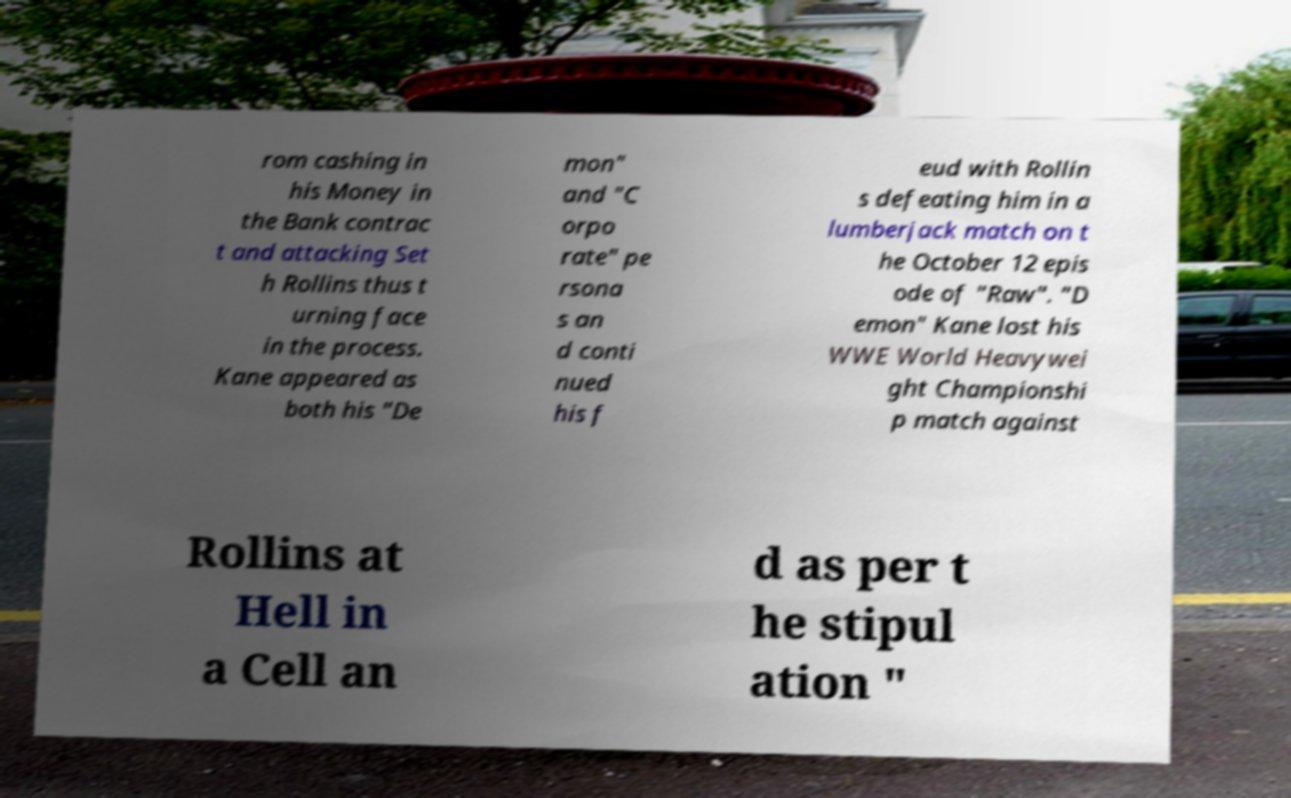Can you read and provide the text displayed in the image?This photo seems to have some interesting text. Can you extract and type it out for me? rom cashing in his Money in the Bank contrac t and attacking Set h Rollins thus t urning face in the process. Kane appeared as both his "De mon" and "C orpo rate" pe rsona s an d conti nued his f eud with Rollin s defeating him in a lumberjack match on t he October 12 epis ode of "Raw". "D emon" Kane lost his WWE World Heavywei ght Championshi p match against Rollins at Hell in a Cell an d as per t he stipul ation " 